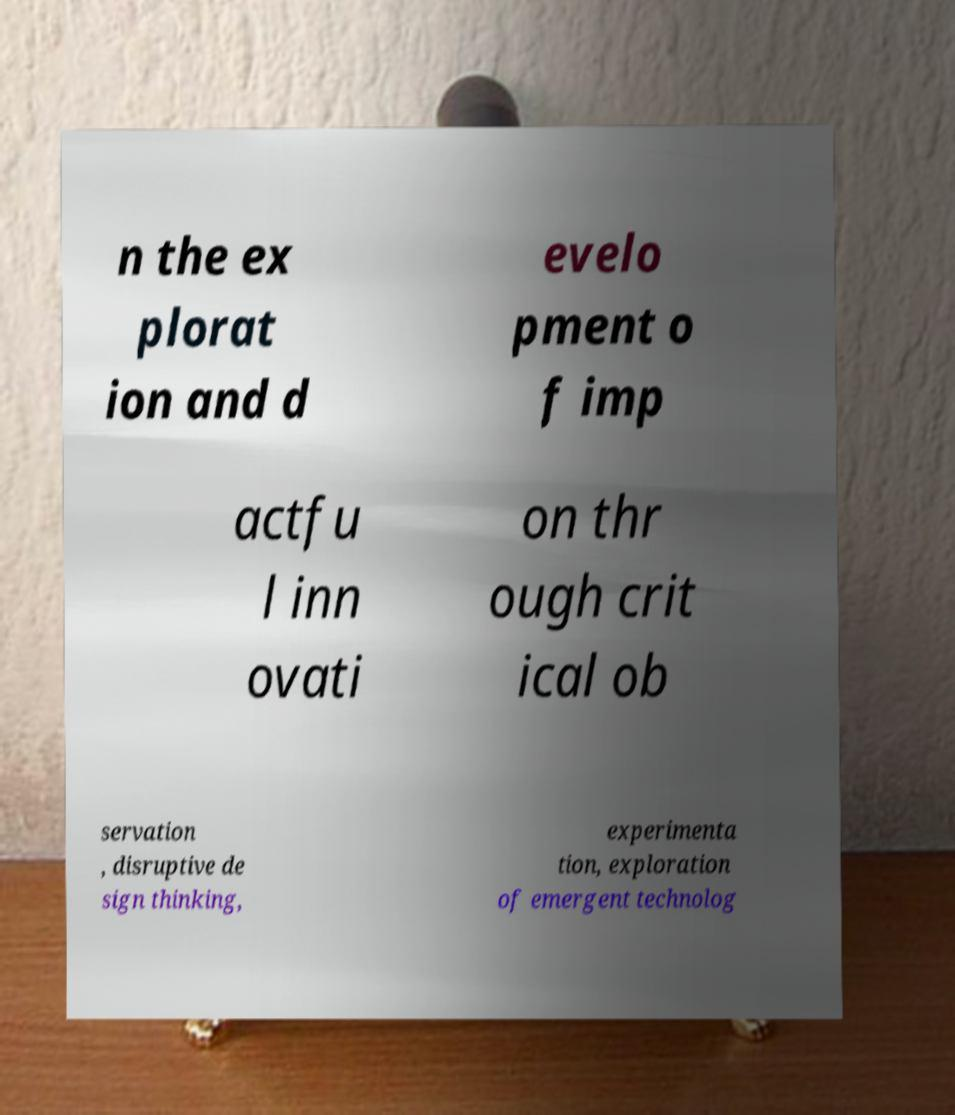Please identify and transcribe the text found in this image. n the ex plorat ion and d evelo pment o f imp actfu l inn ovati on thr ough crit ical ob servation , disruptive de sign thinking, experimenta tion, exploration of emergent technolog 